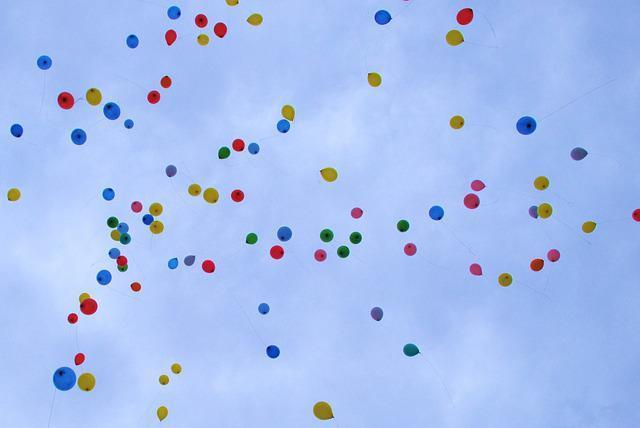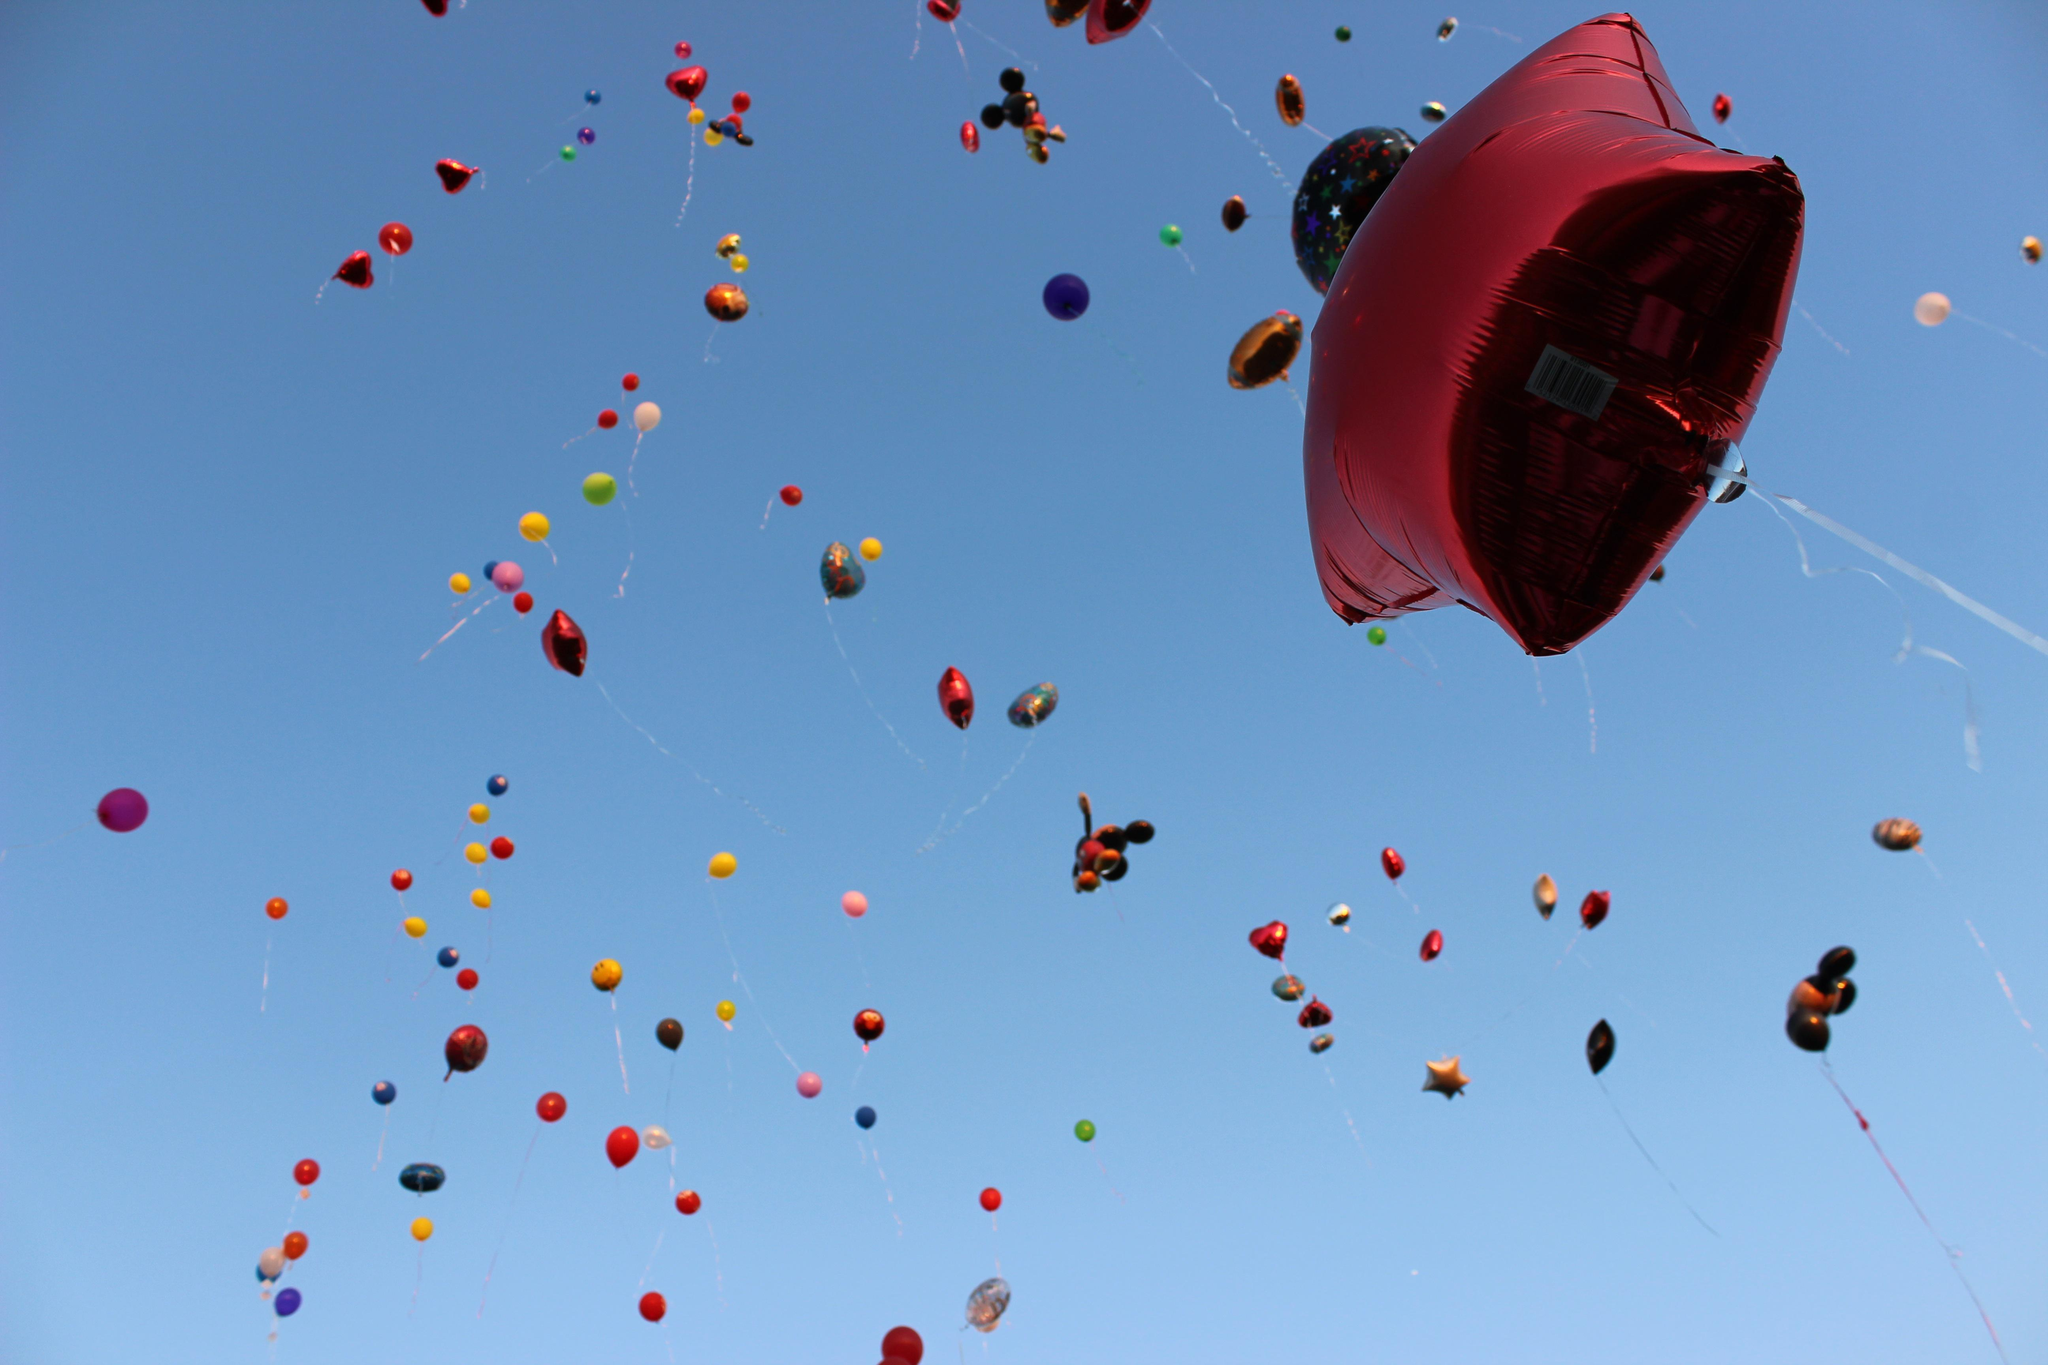The first image is the image on the left, the second image is the image on the right. Examine the images to the left and right. Is the description "All images show more than six balloons in the air." accurate? Answer yes or no. Yes. The first image is the image on the left, the second image is the image on the right. Assess this claim about the two images: "Both images show many different colored balloons against the blue sky.". Correct or not? Answer yes or no. Yes. 